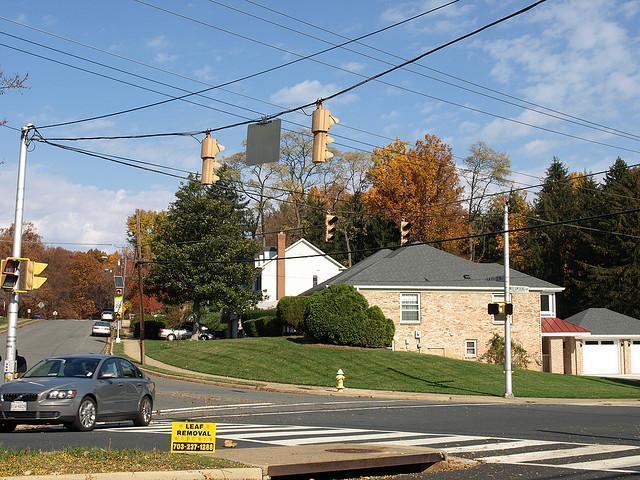What kind of trash can the company advertising on yellow sign help with?
Choose the correct response and explain in the format: 'Answer: answer
Rationale: rationale.'
Options: Construction, appliance, recyclable, leaf. Answer: leaf.
Rationale: The sign is advertising leaf removal. 